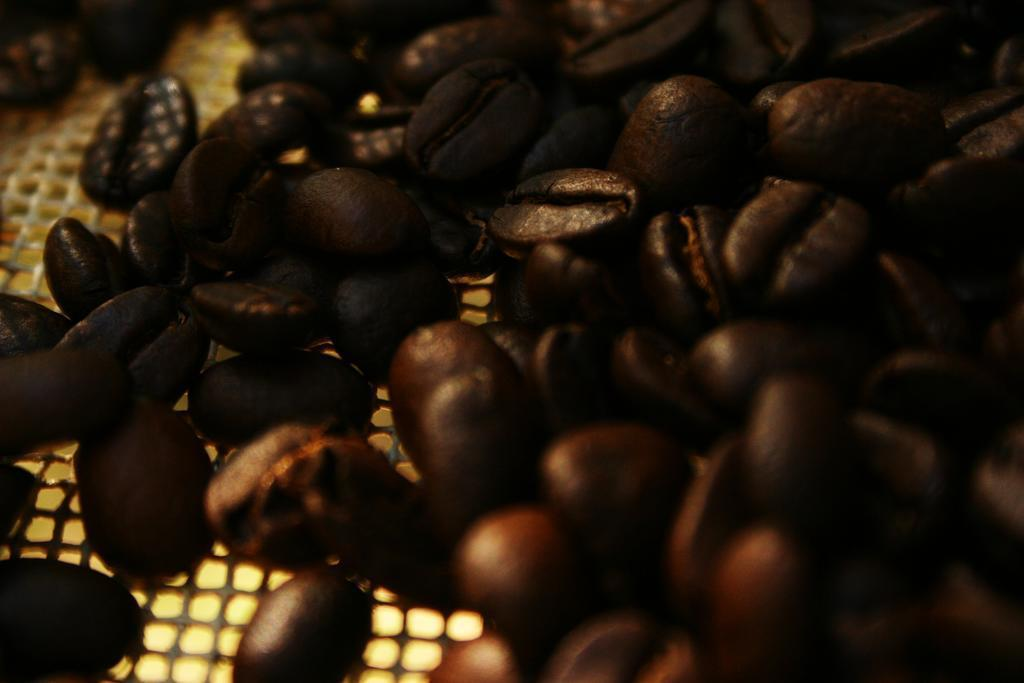What is present in the image? There are coffee beans in the image. Where are the coffee beans located? The coffee beans are on a platform. What type of heart is visible in the image? There is no heart present in the image; it features coffee beans on a platform. What type of knowledge can be gained from the image? The image does not convey any specific knowledge; it simply shows coffee beans on a platform. 